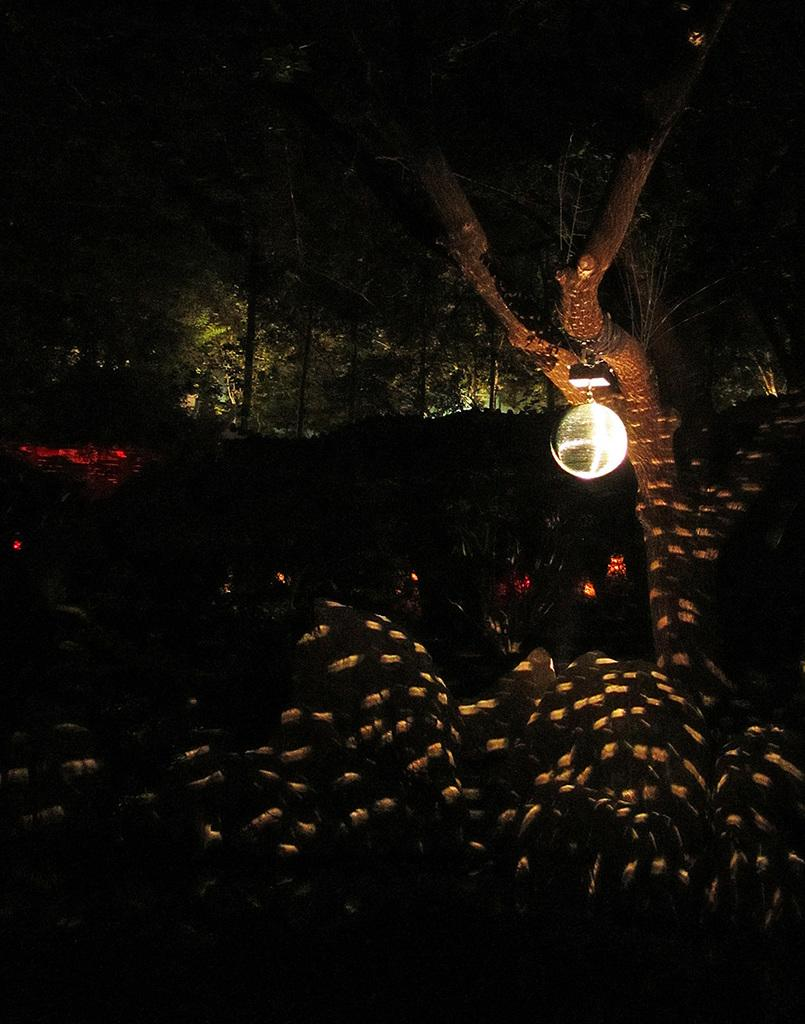What type of natural vegetation is present in the image? There is a group of trees in the image. Can you describe any additional features of the trees? Yes, there is a light attached to one of the trees. What type of sand can be seen on the ground near the trees in the image? There is no sand visible in the image; it features a group of trees with a light attached to one of them. 